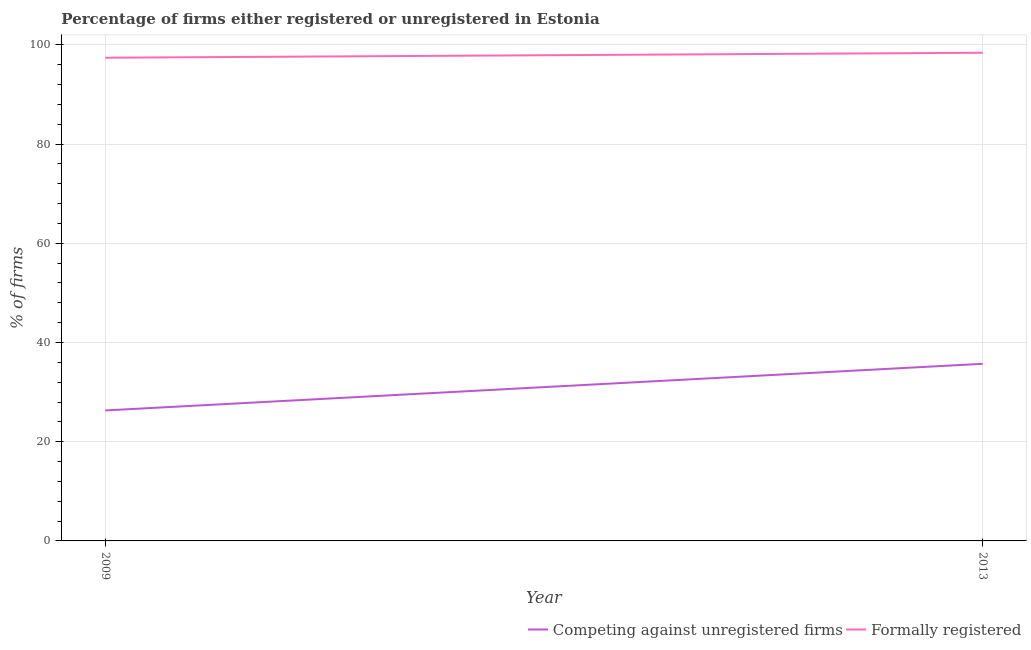How many different coloured lines are there?
Your response must be concise. 2. What is the percentage of registered firms in 2009?
Offer a very short reply. 26.3. Across all years, what is the maximum percentage of formally registered firms?
Provide a succinct answer. 98.4. Across all years, what is the minimum percentage of registered firms?
Your answer should be compact. 26.3. In which year was the percentage of formally registered firms maximum?
Give a very brief answer. 2013. What is the difference between the percentage of registered firms in 2009 and that in 2013?
Keep it short and to the point. -9.4. What is the difference between the percentage of formally registered firms in 2009 and the percentage of registered firms in 2013?
Provide a short and direct response. 61.7. What is the average percentage of registered firms per year?
Your answer should be compact. 31. In the year 2009, what is the difference between the percentage of formally registered firms and percentage of registered firms?
Your answer should be very brief. 71.1. In how many years, is the percentage of registered firms greater than 44 %?
Your response must be concise. 0. What is the ratio of the percentage of formally registered firms in 2009 to that in 2013?
Offer a terse response. 0.99. Is the percentage of formally registered firms in 2009 less than that in 2013?
Offer a very short reply. Yes. In how many years, is the percentage of registered firms greater than the average percentage of registered firms taken over all years?
Provide a succinct answer. 1. Is the percentage of formally registered firms strictly less than the percentage of registered firms over the years?
Offer a very short reply. No. How many lines are there?
Give a very brief answer. 2. What is the difference between two consecutive major ticks on the Y-axis?
Make the answer very short. 20. Are the values on the major ticks of Y-axis written in scientific E-notation?
Offer a very short reply. No. Does the graph contain grids?
Provide a succinct answer. Yes. How many legend labels are there?
Ensure brevity in your answer.  2. How are the legend labels stacked?
Ensure brevity in your answer.  Horizontal. What is the title of the graph?
Your answer should be very brief. Percentage of firms either registered or unregistered in Estonia. What is the label or title of the Y-axis?
Your response must be concise. % of firms. What is the % of firms in Competing against unregistered firms in 2009?
Your answer should be very brief. 26.3. What is the % of firms in Formally registered in 2009?
Keep it short and to the point. 97.4. What is the % of firms of Competing against unregistered firms in 2013?
Your answer should be very brief. 35.7. What is the % of firms of Formally registered in 2013?
Keep it short and to the point. 98.4. Across all years, what is the maximum % of firms of Competing against unregistered firms?
Your answer should be compact. 35.7. Across all years, what is the maximum % of firms in Formally registered?
Offer a very short reply. 98.4. Across all years, what is the minimum % of firms of Competing against unregistered firms?
Ensure brevity in your answer.  26.3. Across all years, what is the minimum % of firms of Formally registered?
Keep it short and to the point. 97.4. What is the total % of firms of Formally registered in the graph?
Your answer should be compact. 195.8. What is the difference between the % of firms of Formally registered in 2009 and that in 2013?
Offer a terse response. -1. What is the difference between the % of firms of Competing against unregistered firms in 2009 and the % of firms of Formally registered in 2013?
Offer a terse response. -72.1. What is the average % of firms in Competing against unregistered firms per year?
Offer a terse response. 31. What is the average % of firms in Formally registered per year?
Offer a very short reply. 97.9. In the year 2009, what is the difference between the % of firms in Competing against unregistered firms and % of firms in Formally registered?
Ensure brevity in your answer.  -71.1. In the year 2013, what is the difference between the % of firms in Competing against unregistered firms and % of firms in Formally registered?
Ensure brevity in your answer.  -62.7. What is the ratio of the % of firms of Competing against unregistered firms in 2009 to that in 2013?
Give a very brief answer. 0.74. What is the difference between the highest and the second highest % of firms in Formally registered?
Provide a succinct answer. 1. What is the difference between the highest and the lowest % of firms of Formally registered?
Provide a succinct answer. 1. 